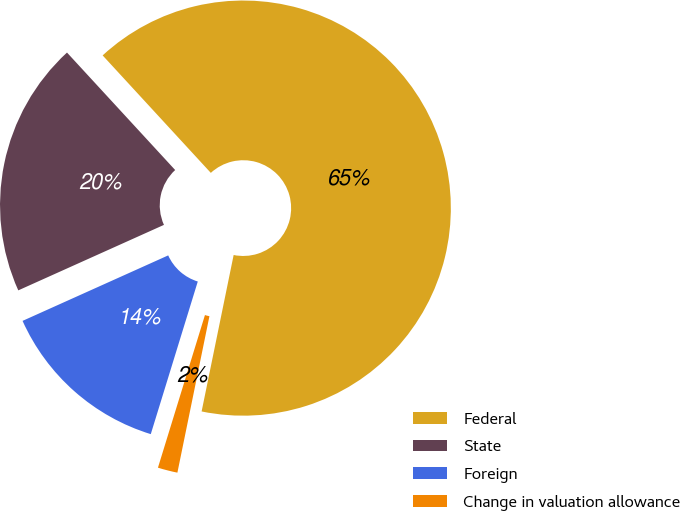<chart> <loc_0><loc_0><loc_500><loc_500><pie_chart><fcel>Federal<fcel>State<fcel>Foreign<fcel>Change in valuation allowance<nl><fcel>65.06%<fcel>19.88%<fcel>13.52%<fcel>1.54%<nl></chart> 